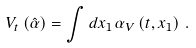<formula> <loc_0><loc_0><loc_500><loc_500>V _ { t } \left ( \hat { \alpha } \right ) = \int d x _ { 1 } \, \alpha _ { V } \left ( t , x _ { 1 } \right ) \, .</formula> 